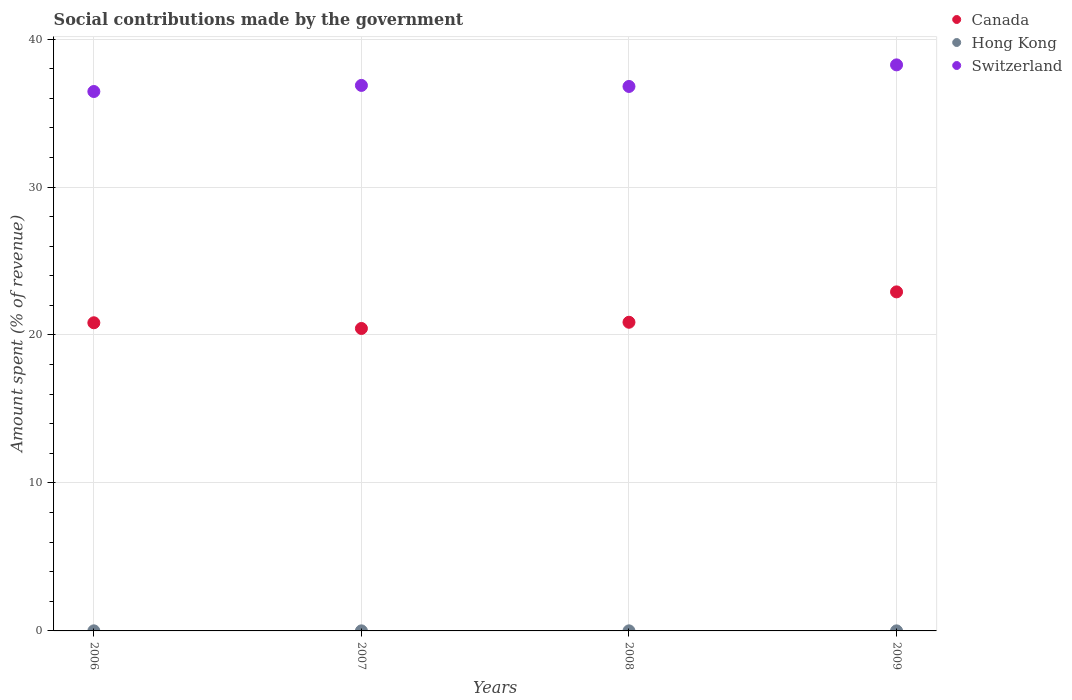What is the amount spent (in %) on social contributions in Hong Kong in 2009?
Give a very brief answer. 0. Across all years, what is the maximum amount spent (in %) on social contributions in Hong Kong?
Offer a terse response. 0.01. Across all years, what is the minimum amount spent (in %) on social contributions in Hong Kong?
Provide a short and direct response. 0. In which year was the amount spent (in %) on social contributions in Switzerland maximum?
Give a very brief answer. 2009. In which year was the amount spent (in %) on social contributions in Hong Kong minimum?
Offer a very short reply. 2009. What is the total amount spent (in %) on social contributions in Canada in the graph?
Provide a succinct answer. 85.04. What is the difference between the amount spent (in %) on social contributions in Hong Kong in 2007 and that in 2009?
Give a very brief answer. 0. What is the difference between the amount spent (in %) on social contributions in Switzerland in 2009 and the amount spent (in %) on social contributions in Hong Kong in 2007?
Make the answer very short. 38.25. What is the average amount spent (in %) on social contributions in Canada per year?
Give a very brief answer. 21.26. In the year 2009, what is the difference between the amount spent (in %) on social contributions in Switzerland and amount spent (in %) on social contributions in Hong Kong?
Make the answer very short. 38.25. What is the ratio of the amount spent (in %) on social contributions in Switzerland in 2006 to that in 2008?
Give a very brief answer. 0.99. Is the amount spent (in %) on social contributions in Hong Kong in 2006 less than that in 2009?
Provide a short and direct response. No. Is the difference between the amount spent (in %) on social contributions in Switzerland in 2006 and 2009 greater than the difference between the amount spent (in %) on social contributions in Hong Kong in 2006 and 2009?
Give a very brief answer. No. What is the difference between the highest and the second highest amount spent (in %) on social contributions in Switzerland?
Keep it short and to the point. 1.39. What is the difference between the highest and the lowest amount spent (in %) on social contributions in Canada?
Provide a short and direct response. 2.47. In how many years, is the amount spent (in %) on social contributions in Hong Kong greater than the average amount spent (in %) on social contributions in Hong Kong taken over all years?
Offer a very short reply. 2. Is the amount spent (in %) on social contributions in Switzerland strictly greater than the amount spent (in %) on social contributions in Hong Kong over the years?
Provide a succinct answer. Yes. How many dotlines are there?
Keep it short and to the point. 3. How many years are there in the graph?
Offer a very short reply. 4. What is the difference between two consecutive major ticks on the Y-axis?
Your response must be concise. 10. Are the values on the major ticks of Y-axis written in scientific E-notation?
Offer a terse response. No. Does the graph contain any zero values?
Offer a terse response. No. Where does the legend appear in the graph?
Make the answer very short. Top right. What is the title of the graph?
Your answer should be compact. Social contributions made by the government. What is the label or title of the X-axis?
Provide a succinct answer. Years. What is the label or title of the Y-axis?
Give a very brief answer. Amount spent (% of revenue). What is the Amount spent (% of revenue) of Canada in 2006?
Your answer should be compact. 20.83. What is the Amount spent (% of revenue) of Hong Kong in 2006?
Keep it short and to the point. 0.01. What is the Amount spent (% of revenue) of Switzerland in 2006?
Your answer should be compact. 36.46. What is the Amount spent (% of revenue) of Canada in 2007?
Your answer should be very brief. 20.44. What is the Amount spent (% of revenue) in Hong Kong in 2007?
Your answer should be very brief. 0. What is the Amount spent (% of revenue) of Switzerland in 2007?
Ensure brevity in your answer.  36.87. What is the Amount spent (% of revenue) of Canada in 2008?
Your answer should be compact. 20.86. What is the Amount spent (% of revenue) in Hong Kong in 2008?
Offer a very short reply. 0. What is the Amount spent (% of revenue) of Switzerland in 2008?
Your answer should be compact. 36.8. What is the Amount spent (% of revenue) in Canada in 2009?
Offer a very short reply. 22.91. What is the Amount spent (% of revenue) of Hong Kong in 2009?
Keep it short and to the point. 0. What is the Amount spent (% of revenue) in Switzerland in 2009?
Make the answer very short. 38.26. Across all years, what is the maximum Amount spent (% of revenue) of Canada?
Your response must be concise. 22.91. Across all years, what is the maximum Amount spent (% of revenue) in Hong Kong?
Provide a short and direct response. 0.01. Across all years, what is the maximum Amount spent (% of revenue) of Switzerland?
Your response must be concise. 38.26. Across all years, what is the minimum Amount spent (% of revenue) in Canada?
Provide a succinct answer. 20.44. Across all years, what is the minimum Amount spent (% of revenue) of Hong Kong?
Give a very brief answer. 0. Across all years, what is the minimum Amount spent (% of revenue) of Switzerland?
Your answer should be compact. 36.46. What is the total Amount spent (% of revenue) in Canada in the graph?
Keep it short and to the point. 85.04. What is the total Amount spent (% of revenue) of Hong Kong in the graph?
Offer a very short reply. 0.02. What is the total Amount spent (% of revenue) in Switzerland in the graph?
Keep it short and to the point. 148.38. What is the difference between the Amount spent (% of revenue) of Canada in 2006 and that in 2007?
Your answer should be compact. 0.39. What is the difference between the Amount spent (% of revenue) of Switzerland in 2006 and that in 2007?
Provide a short and direct response. -0.41. What is the difference between the Amount spent (% of revenue) in Canada in 2006 and that in 2008?
Ensure brevity in your answer.  -0.03. What is the difference between the Amount spent (% of revenue) of Hong Kong in 2006 and that in 2008?
Your answer should be compact. 0. What is the difference between the Amount spent (% of revenue) of Switzerland in 2006 and that in 2008?
Offer a terse response. -0.34. What is the difference between the Amount spent (% of revenue) of Canada in 2006 and that in 2009?
Offer a very short reply. -2.09. What is the difference between the Amount spent (% of revenue) of Hong Kong in 2006 and that in 2009?
Keep it short and to the point. 0. What is the difference between the Amount spent (% of revenue) of Switzerland in 2006 and that in 2009?
Your answer should be very brief. -1.8. What is the difference between the Amount spent (% of revenue) of Canada in 2007 and that in 2008?
Offer a terse response. -0.42. What is the difference between the Amount spent (% of revenue) of Hong Kong in 2007 and that in 2008?
Provide a succinct answer. -0. What is the difference between the Amount spent (% of revenue) of Switzerland in 2007 and that in 2008?
Provide a succinct answer. 0.07. What is the difference between the Amount spent (% of revenue) in Canada in 2007 and that in 2009?
Provide a succinct answer. -2.47. What is the difference between the Amount spent (% of revenue) in Switzerland in 2007 and that in 2009?
Keep it short and to the point. -1.39. What is the difference between the Amount spent (% of revenue) of Canada in 2008 and that in 2009?
Your answer should be compact. -2.05. What is the difference between the Amount spent (% of revenue) in Hong Kong in 2008 and that in 2009?
Your response must be concise. 0. What is the difference between the Amount spent (% of revenue) in Switzerland in 2008 and that in 2009?
Provide a short and direct response. -1.46. What is the difference between the Amount spent (% of revenue) in Canada in 2006 and the Amount spent (% of revenue) in Hong Kong in 2007?
Offer a terse response. 20.82. What is the difference between the Amount spent (% of revenue) of Canada in 2006 and the Amount spent (% of revenue) of Switzerland in 2007?
Provide a succinct answer. -16.04. What is the difference between the Amount spent (% of revenue) of Hong Kong in 2006 and the Amount spent (% of revenue) of Switzerland in 2007?
Make the answer very short. -36.86. What is the difference between the Amount spent (% of revenue) in Canada in 2006 and the Amount spent (% of revenue) in Hong Kong in 2008?
Offer a very short reply. 20.82. What is the difference between the Amount spent (% of revenue) of Canada in 2006 and the Amount spent (% of revenue) of Switzerland in 2008?
Your response must be concise. -15.97. What is the difference between the Amount spent (% of revenue) in Hong Kong in 2006 and the Amount spent (% of revenue) in Switzerland in 2008?
Offer a terse response. -36.79. What is the difference between the Amount spent (% of revenue) of Canada in 2006 and the Amount spent (% of revenue) of Hong Kong in 2009?
Make the answer very short. 20.82. What is the difference between the Amount spent (% of revenue) of Canada in 2006 and the Amount spent (% of revenue) of Switzerland in 2009?
Provide a short and direct response. -17.43. What is the difference between the Amount spent (% of revenue) in Hong Kong in 2006 and the Amount spent (% of revenue) in Switzerland in 2009?
Provide a succinct answer. -38.25. What is the difference between the Amount spent (% of revenue) of Canada in 2007 and the Amount spent (% of revenue) of Hong Kong in 2008?
Your response must be concise. 20.44. What is the difference between the Amount spent (% of revenue) in Canada in 2007 and the Amount spent (% of revenue) in Switzerland in 2008?
Offer a terse response. -16.36. What is the difference between the Amount spent (% of revenue) of Hong Kong in 2007 and the Amount spent (% of revenue) of Switzerland in 2008?
Offer a terse response. -36.79. What is the difference between the Amount spent (% of revenue) in Canada in 2007 and the Amount spent (% of revenue) in Hong Kong in 2009?
Offer a very short reply. 20.44. What is the difference between the Amount spent (% of revenue) in Canada in 2007 and the Amount spent (% of revenue) in Switzerland in 2009?
Make the answer very short. -17.81. What is the difference between the Amount spent (% of revenue) in Hong Kong in 2007 and the Amount spent (% of revenue) in Switzerland in 2009?
Your answer should be compact. -38.25. What is the difference between the Amount spent (% of revenue) in Canada in 2008 and the Amount spent (% of revenue) in Hong Kong in 2009?
Keep it short and to the point. 20.86. What is the difference between the Amount spent (% of revenue) of Canada in 2008 and the Amount spent (% of revenue) of Switzerland in 2009?
Ensure brevity in your answer.  -17.39. What is the difference between the Amount spent (% of revenue) of Hong Kong in 2008 and the Amount spent (% of revenue) of Switzerland in 2009?
Offer a very short reply. -38.25. What is the average Amount spent (% of revenue) in Canada per year?
Your answer should be compact. 21.26. What is the average Amount spent (% of revenue) in Hong Kong per year?
Give a very brief answer. 0. What is the average Amount spent (% of revenue) of Switzerland per year?
Keep it short and to the point. 37.09. In the year 2006, what is the difference between the Amount spent (% of revenue) in Canada and Amount spent (% of revenue) in Hong Kong?
Make the answer very short. 20.82. In the year 2006, what is the difference between the Amount spent (% of revenue) of Canada and Amount spent (% of revenue) of Switzerland?
Give a very brief answer. -15.63. In the year 2006, what is the difference between the Amount spent (% of revenue) in Hong Kong and Amount spent (% of revenue) in Switzerland?
Ensure brevity in your answer.  -36.45. In the year 2007, what is the difference between the Amount spent (% of revenue) of Canada and Amount spent (% of revenue) of Hong Kong?
Your response must be concise. 20.44. In the year 2007, what is the difference between the Amount spent (% of revenue) in Canada and Amount spent (% of revenue) in Switzerland?
Offer a very short reply. -16.43. In the year 2007, what is the difference between the Amount spent (% of revenue) in Hong Kong and Amount spent (% of revenue) in Switzerland?
Provide a succinct answer. -36.86. In the year 2008, what is the difference between the Amount spent (% of revenue) in Canada and Amount spent (% of revenue) in Hong Kong?
Your response must be concise. 20.86. In the year 2008, what is the difference between the Amount spent (% of revenue) of Canada and Amount spent (% of revenue) of Switzerland?
Offer a very short reply. -15.94. In the year 2008, what is the difference between the Amount spent (% of revenue) in Hong Kong and Amount spent (% of revenue) in Switzerland?
Offer a terse response. -36.79. In the year 2009, what is the difference between the Amount spent (% of revenue) in Canada and Amount spent (% of revenue) in Hong Kong?
Provide a short and direct response. 22.91. In the year 2009, what is the difference between the Amount spent (% of revenue) in Canada and Amount spent (% of revenue) in Switzerland?
Offer a very short reply. -15.34. In the year 2009, what is the difference between the Amount spent (% of revenue) in Hong Kong and Amount spent (% of revenue) in Switzerland?
Your answer should be very brief. -38.25. What is the ratio of the Amount spent (% of revenue) of Canada in 2006 to that in 2007?
Offer a terse response. 1.02. What is the ratio of the Amount spent (% of revenue) in Hong Kong in 2006 to that in 2007?
Your answer should be compact. 1.21. What is the ratio of the Amount spent (% of revenue) of Switzerland in 2006 to that in 2007?
Your response must be concise. 0.99. What is the ratio of the Amount spent (% of revenue) of Canada in 2006 to that in 2008?
Offer a terse response. 1. What is the ratio of the Amount spent (% of revenue) in Hong Kong in 2006 to that in 2008?
Offer a terse response. 1.15. What is the ratio of the Amount spent (% of revenue) in Canada in 2006 to that in 2009?
Your response must be concise. 0.91. What is the ratio of the Amount spent (% of revenue) of Hong Kong in 2006 to that in 2009?
Provide a short and direct response. 1.34. What is the ratio of the Amount spent (% of revenue) in Switzerland in 2006 to that in 2009?
Your answer should be very brief. 0.95. What is the ratio of the Amount spent (% of revenue) in Canada in 2007 to that in 2008?
Ensure brevity in your answer.  0.98. What is the ratio of the Amount spent (% of revenue) of Hong Kong in 2007 to that in 2008?
Offer a very short reply. 0.95. What is the ratio of the Amount spent (% of revenue) in Canada in 2007 to that in 2009?
Keep it short and to the point. 0.89. What is the ratio of the Amount spent (% of revenue) of Hong Kong in 2007 to that in 2009?
Offer a terse response. 1.11. What is the ratio of the Amount spent (% of revenue) of Switzerland in 2007 to that in 2009?
Provide a short and direct response. 0.96. What is the ratio of the Amount spent (% of revenue) of Canada in 2008 to that in 2009?
Make the answer very short. 0.91. What is the ratio of the Amount spent (% of revenue) in Hong Kong in 2008 to that in 2009?
Offer a very short reply. 1.16. What is the ratio of the Amount spent (% of revenue) of Switzerland in 2008 to that in 2009?
Make the answer very short. 0.96. What is the difference between the highest and the second highest Amount spent (% of revenue) of Canada?
Ensure brevity in your answer.  2.05. What is the difference between the highest and the second highest Amount spent (% of revenue) in Hong Kong?
Offer a very short reply. 0. What is the difference between the highest and the second highest Amount spent (% of revenue) in Switzerland?
Ensure brevity in your answer.  1.39. What is the difference between the highest and the lowest Amount spent (% of revenue) in Canada?
Ensure brevity in your answer.  2.47. What is the difference between the highest and the lowest Amount spent (% of revenue) in Hong Kong?
Make the answer very short. 0. What is the difference between the highest and the lowest Amount spent (% of revenue) in Switzerland?
Ensure brevity in your answer.  1.8. 